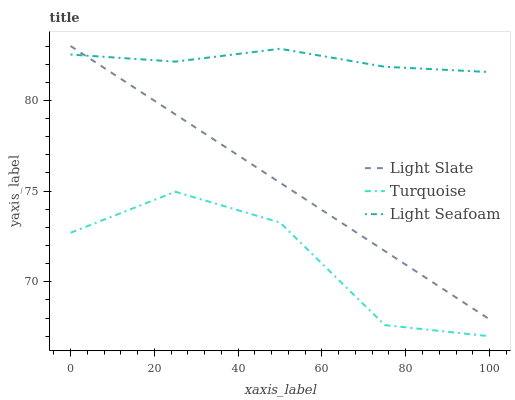Does Turquoise have the minimum area under the curve?
Answer yes or no. Yes. Does Light Seafoam have the maximum area under the curve?
Answer yes or no. Yes. Does Light Seafoam have the minimum area under the curve?
Answer yes or no. No. Does Turquoise have the maximum area under the curve?
Answer yes or no. No. Is Light Slate the smoothest?
Answer yes or no. Yes. Is Turquoise the roughest?
Answer yes or no. Yes. Is Light Seafoam the smoothest?
Answer yes or no. No. Is Light Seafoam the roughest?
Answer yes or no. No. Does Turquoise have the lowest value?
Answer yes or no. Yes. Does Light Seafoam have the lowest value?
Answer yes or no. No. Does Light Slate have the highest value?
Answer yes or no. Yes. Does Light Seafoam have the highest value?
Answer yes or no. No. Is Turquoise less than Light Slate?
Answer yes or no. Yes. Is Light Slate greater than Turquoise?
Answer yes or no. Yes. Does Light Seafoam intersect Light Slate?
Answer yes or no. Yes. Is Light Seafoam less than Light Slate?
Answer yes or no. No. Is Light Seafoam greater than Light Slate?
Answer yes or no. No. Does Turquoise intersect Light Slate?
Answer yes or no. No. 